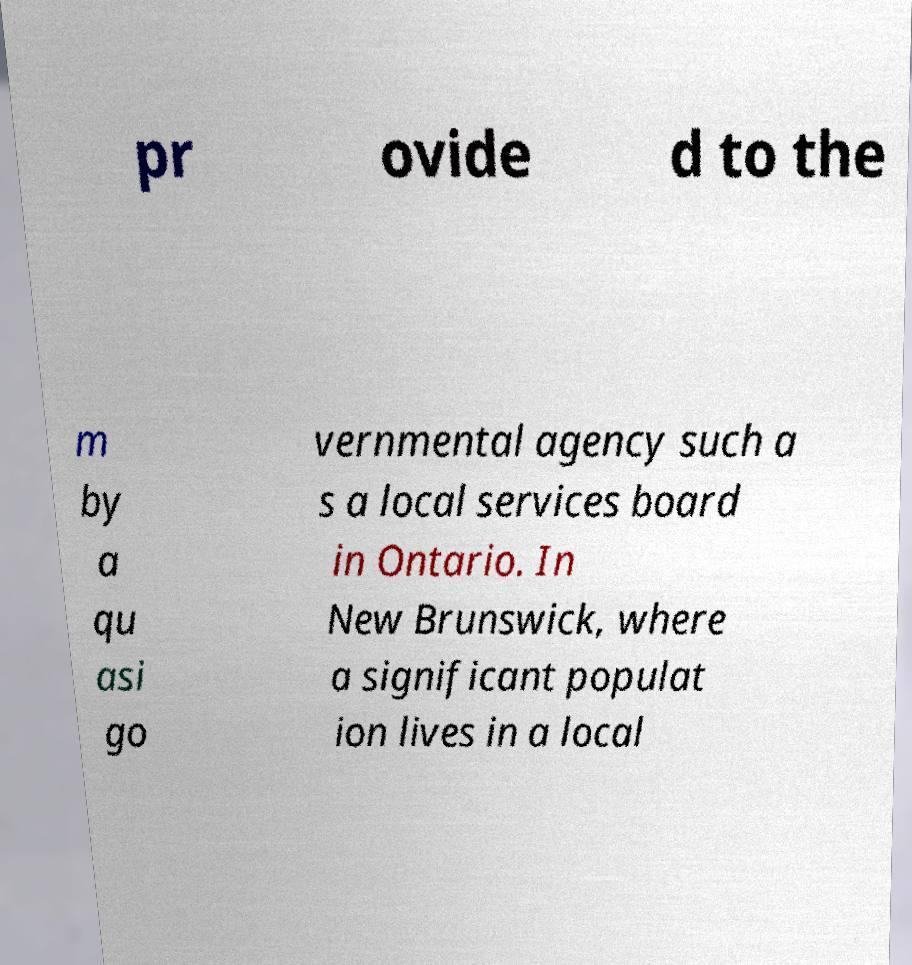I need the written content from this picture converted into text. Can you do that? pr ovide d to the m by a qu asi go vernmental agency such a s a local services board in Ontario. In New Brunswick, where a significant populat ion lives in a local 